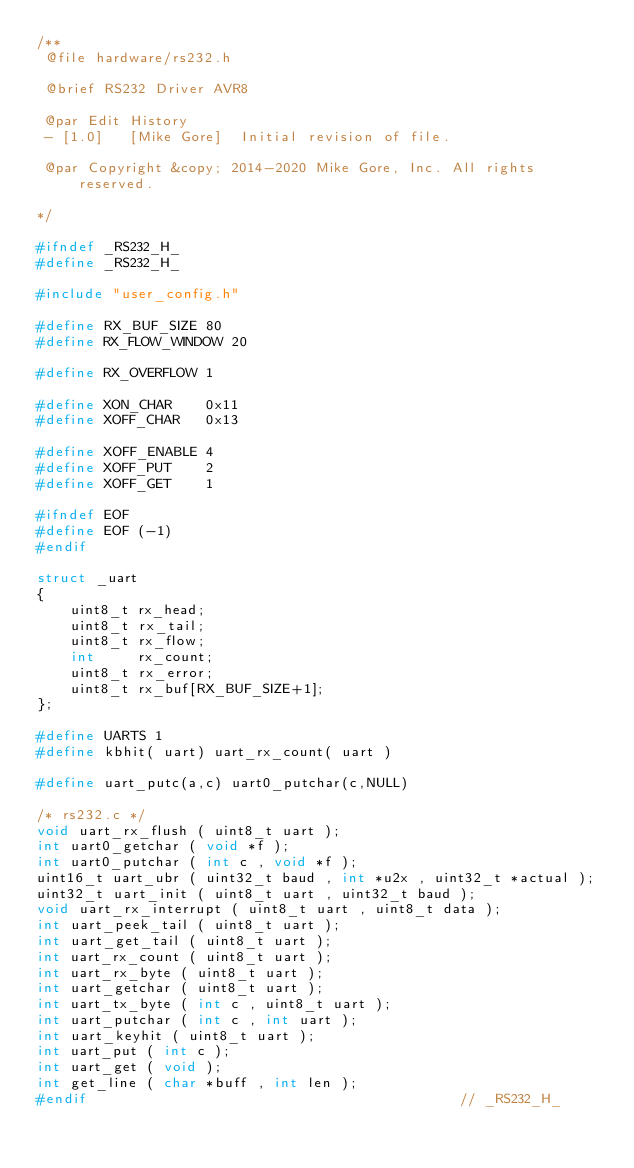<code> <loc_0><loc_0><loc_500><loc_500><_C_>/**
 @file hardware/rs232.h

 @brief RS232 Driver AVR8

 @par Edit History
 - [1.0]   [Mike Gore]  Initial revision of file.

 @par Copyright &copy; 2014-2020 Mike Gore, Inc. All rights reserved.

*/

#ifndef _RS232_H_
#define _RS232_H_

#include "user_config.h"

#define RX_BUF_SIZE 80
#define RX_FLOW_WINDOW 20

#define RX_OVERFLOW 1

#define XON_CHAR    0x11
#define XOFF_CHAR   0x13

#define XOFF_ENABLE 4
#define XOFF_PUT    2
#define XOFF_GET    1

#ifndef EOF
#define EOF (-1)
#endif

struct _uart
{
    uint8_t rx_head;
    uint8_t rx_tail;
    uint8_t rx_flow;
    int     rx_count;
    uint8_t rx_error;
    uint8_t rx_buf[RX_BUF_SIZE+1];
};

#define UARTS 1
#define kbhit( uart) uart_rx_count( uart )

#define uart_putc(a,c) uart0_putchar(c,NULL)

/* rs232.c */
void uart_rx_flush ( uint8_t uart );
int uart0_getchar ( void *f );
int uart0_putchar ( int c , void *f );
uint16_t uart_ubr ( uint32_t baud , int *u2x , uint32_t *actual );
uint32_t uart_init ( uint8_t uart , uint32_t baud );
void uart_rx_interrupt ( uint8_t uart , uint8_t data );
int uart_peek_tail ( uint8_t uart );
int uart_get_tail ( uint8_t uart );
int uart_rx_count ( uint8_t uart );
int uart_rx_byte ( uint8_t uart );
int uart_getchar ( uint8_t uart );
int uart_tx_byte ( int c , uint8_t uart );
int uart_putchar ( int c , int uart );
int uart_keyhit ( uint8_t uart );
int uart_put ( int c );
int uart_get ( void );
int get_line ( char *buff , int len );
#endif                                            // _RS232_H_
</code> 